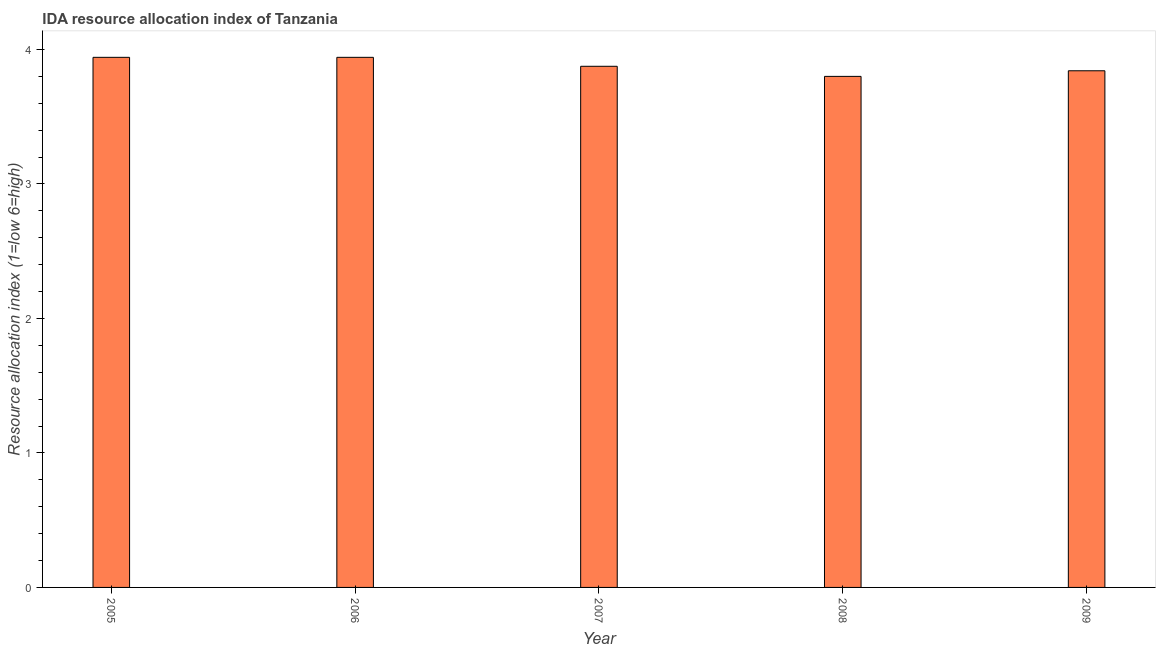Does the graph contain any zero values?
Offer a very short reply. No. Does the graph contain grids?
Your answer should be compact. No. What is the title of the graph?
Provide a succinct answer. IDA resource allocation index of Tanzania. What is the label or title of the Y-axis?
Keep it short and to the point. Resource allocation index (1=low 6=high). What is the ida resource allocation index in 2007?
Provide a succinct answer. 3.88. Across all years, what is the maximum ida resource allocation index?
Offer a terse response. 3.94. Across all years, what is the minimum ida resource allocation index?
Keep it short and to the point. 3.8. In which year was the ida resource allocation index minimum?
Ensure brevity in your answer.  2008. What is the sum of the ida resource allocation index?
Ensure brevity in your answer.  19.4. What is the difference between the ida resource allocation index in 2007 and 2009?
Offer a terse response. 0.03. What is the average ida resource allocation index per year?
Your response must be concise. 3.88. What is the median ida resource allocation index?
Give a very brief answer. 3.88. In how many years, is the ida resource allocation index greater than 3.8 ?
Offer a terse response. 4. Do a majority of the years between 2009 and 2006 (inclusive) have ida resource allocation index greater than 1.6 ?
Your answer should be very brief. Yes. What is the ratio of the ida resource allocation index in 2008 to that in 2009?
Make the answer very short. 0.99. Is the difference between the ida resource allocation index in 2005 and 2009 greater than the difference between any two years?
Your response must be concise. No. What is the difference between the highest and the second highest ida resource allocation index?
Give a very brief answer. 0. What is the difference between the highest and the lowest ida resource allocation index?
Ensure brevity in your answer.  0.14. In how many years, is the ida resource allocation index greater than the average ida resource allocation index taken over all years?
Provide a short and direct response. 2. How many bars are there?
Your response must be concise. 5. Are all the bars in the graph horizontal?
Give a very brief answer. No. How many years are there in the graph?
Provide a short and direct response. 5. What is the difference between two consecutive major ticks on the Y-axis?
Provide a short and direct response. 1. Are the values on the major ticks of Y-axis written in scientific E-notation?
Offer a terse response. No. What is the Resource allocation index (1=low 6=high) in 2005?
Your answer should be very brief. 3.94. What is the Resource allocation index (1=low 6=high) of 2006?
Offer a very short reply. 3.94. What is the Resource allocation index (1=low 6=high) of 2007?
Give a very brief answer. 3.88. What is the Resource allocation index (1=low 6=high) of 2009?
Give a very brief answer. 3.84. What is the difference between the Resource allocation index (1=low 6=high) in 2005 and 2006?
Your answer should be compact. 0. What is the difference between the Resource allocation index (1=low 6=high) in 2005 and 2007?
Ensure brevity in your answer.  0.07. What is the difference between the Resource allocation index (1=low 6=high) in 2005 and 2008?
Keep it short and to the point. 0.14. What is the difference between the Resource allocation index (1=low 6=high) in 2006 and 2007?
Your answer should be very brief. 0.07. What is the difference between the Resource allocation index (1=low 6=high) in 2006 and 2008?
Keep it short and to the point. 0.14. What is the difference between the Resource allocation index (1=low 6=high) in 2006 and 2009?
Your answer should be compact. 0.1. What is the difference between the Resource allocation index (1=low 6=high) in 2007 and 2008?
Your answer should be very brief. 0.07. What is the difference between the Resource allocation index (1=low 6=high) in 2007 and 2009?
Keep it short and to the point. 0.03. What is the difference between the Resource allocation index (1=low 6=high) in 2008 and 2009?
Provide a short and direct response. -0.04. What is the ratio of the Resource allocation index (1=low 6=high) in 2005 to that in 2007?
Make the answer very short. 1.02. What is the ratio of the Resource allocation index (1=low 6=high) in 2005 to that in 2008?
Give a very brief answer. 1.04. What is the ratio of the Resource allocation index (1=low 6=high) in 2006 to that in 2007?
Offer a very short reply. 1.02. What is the ratio of the Resource allocation index (1=low 6=high) in 2006 to that in 2008?
Make the answer very short. 1.04. What is the ratio of the Resource allocation index (1=low 6=high) in 2007 to that in 2008?
Give a very brief answer. 1.02. 